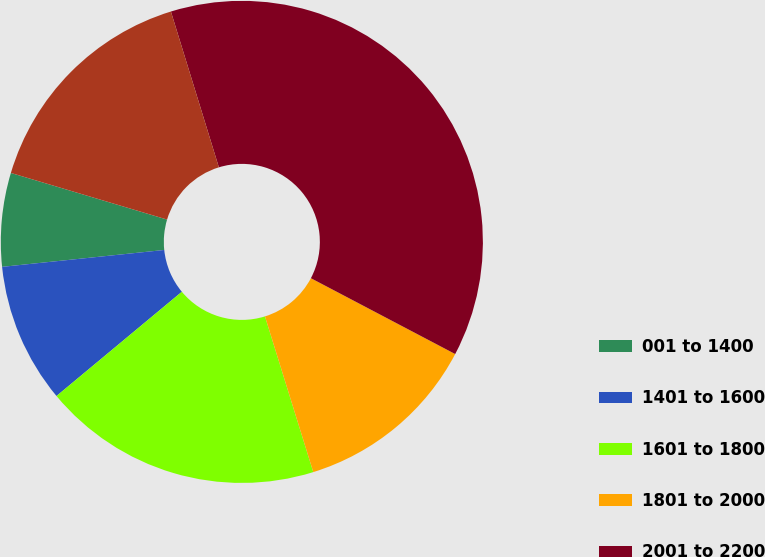Convert chart to OTSL. <chart><loc_0><loc_0><loc_500><loc_500><pie_chart><fcel>001 to 1400<fcel>1401 to 1600<fcel>1601 to 1800<fcel>1801 to 2000<fcel>2001 to 2200<fcel>2401 to 2600<nl><fcel>6.27%<fcel>9.39%<fcel>18.75%<fcel>12.51%<fcel>37.46%<fcel>15.63%<nl></chart> 